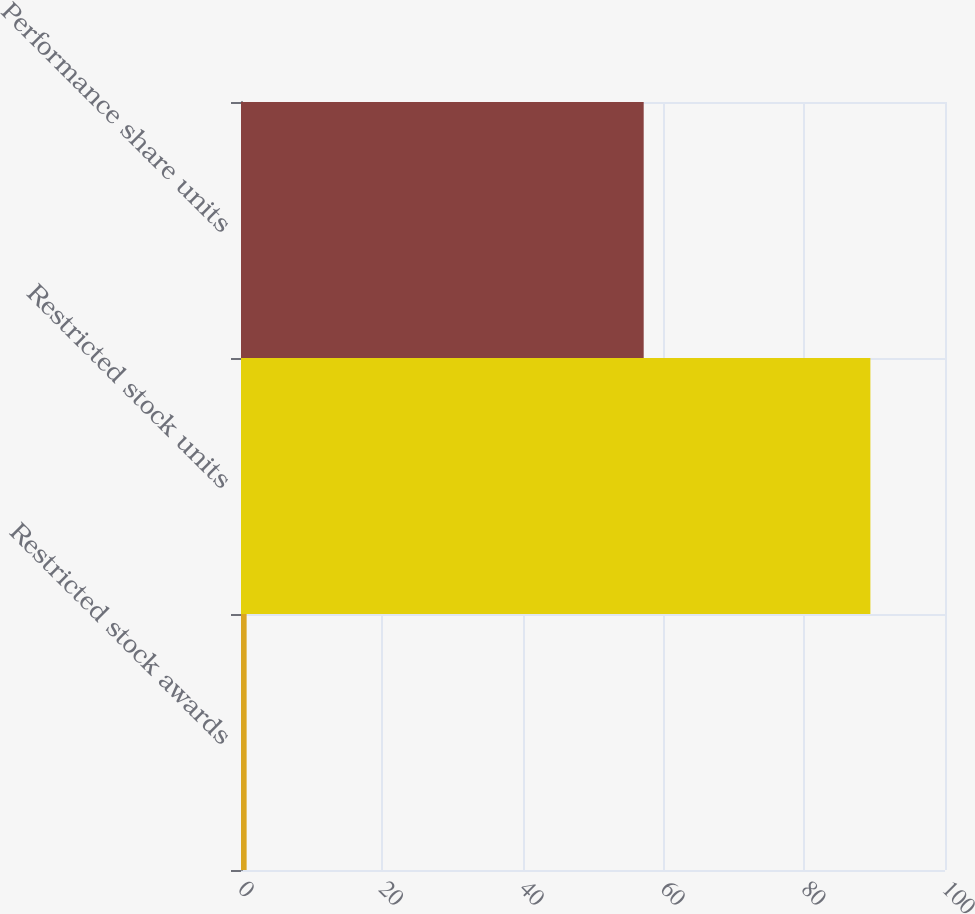Convert chart. <chart><loc_0><loc_0><loc_500><loc_500><bar_chart><fcel>Restricted stock awards<fcel>Restricted stock units<fcel>Performance share units<nl><fcel>0.8<fcel>89.4<fcel>57.2<nl></chart> 